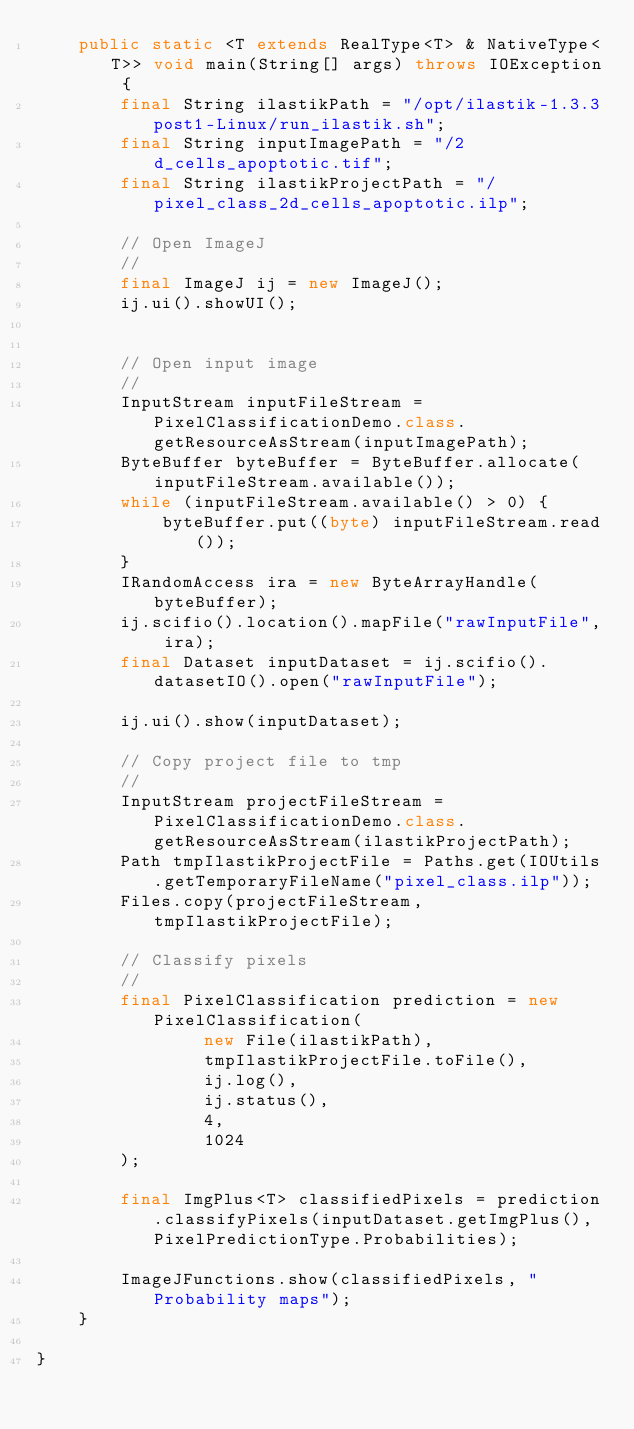<code> <loc_0><loc_0><loc_500><loc_500><_Java_>    public static <T extends RealType<T> & NativeType<T>> void main(String[] args) throws IOException {
        final String ilastikPath = "/opt/ilastik-1.3.3post1-Linux/run_ilastik.sh";
        final String inputImagePath = "/2d_cells_apoptotic.tif";
        final String ilastikProjectPath = "/pixel_class_2d_cells_apoptotic.ilp";

        // Open ImageJ
        //
        final ImageJ ij = new ImageJ();
        ij.ui().showUI();


        // Open input image
        //
        InputStream inputFileStream = PixelClassificationDemo.class.getResourceAsStream(inputImagePath);
        ByteBuffer byteBuffer = ByteBuffer.allocate(inputFileStream.available());
        while (inputFileStream.available() > 0) {
            byteBuffer.put((byte) inputFileStream.read());
        }
        IRandomAccess ira = new ByteArrayHandle(byteBuffer);
        ij.scifio().location().mapFile("rawInputFile", ira);
        final Dataset inputDataset = ij.scifio().datasetIO().open("rawInputFile");

        ij.ui().show(inputDataset);

        // Copy project file to tmp
        //
        InputStream projectFileStream = PixelClassificationDemo.class.getResourceAsStream(ilastikProjectPath);
        Path tmpIlastikProjectFile = Paths.get(IOUtils.getTemporaryFileName("pixel_class.ilp"));
        Files.copy(projectFileStream, tmpIlastikProjectFile);

        // Classify pixels
        //
        final PixelClassification prediction = new PixelClassification(
                new File(ilastikPath),
                tmpIlastikProjectFile.toFile(),
                ij.log(),
                ij.status(),
                4,
                1024
        );

        final ImgPlus<T> classifiedPixels = prediction.classifyPixels(inputDataset.getImgPlus(), PixelPredictionType.Probabilities);

        ImageJFunctions.show(classifiedPixels, "Probability maps");
    }

}
</code> 